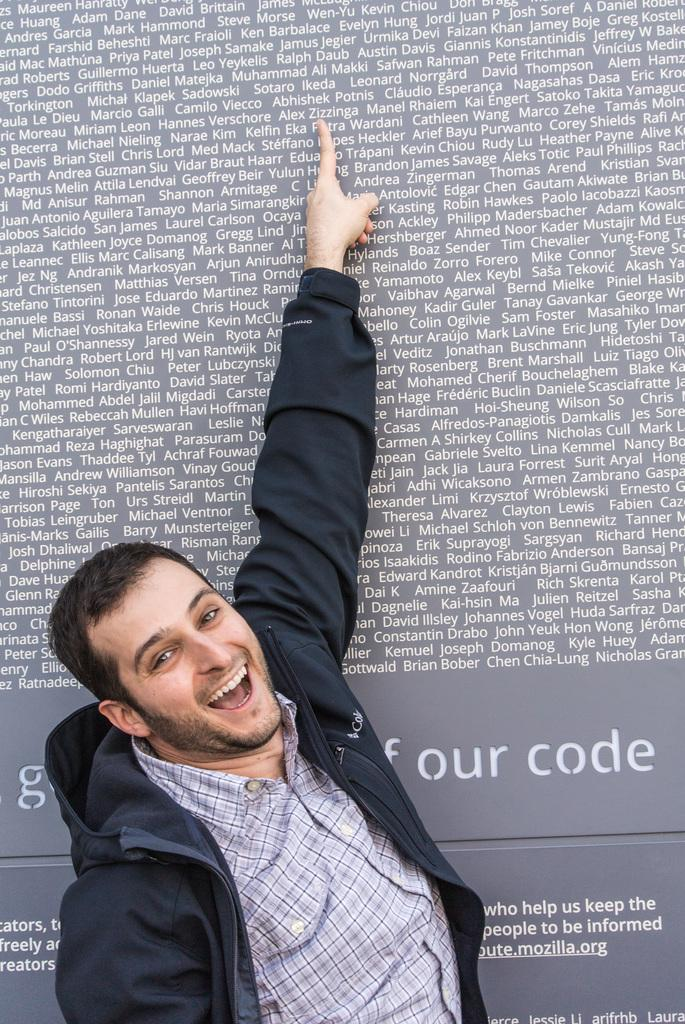What is the main subject of the image? The main subject of the image is a man. What is the man wearing? The man is wearing a t-shirt and a jacket. What is the man's facial expression? The man is smiling. What direction is the man pointing? The man is pointing upwards. What else can be seen in the image? There is a board with text on it. What type of knowledge can be gained from the bushes in the image? There is no bus present in the image, so no knowledge can be gained from a bus. 